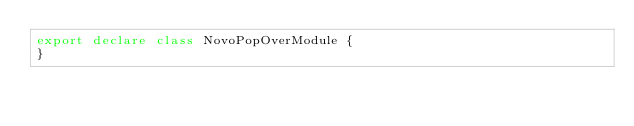<code> <loc_0><loc_0><loc_500><loc_500><_TypeScript_>export declare class NovoPopOverModule {
}
</code> 